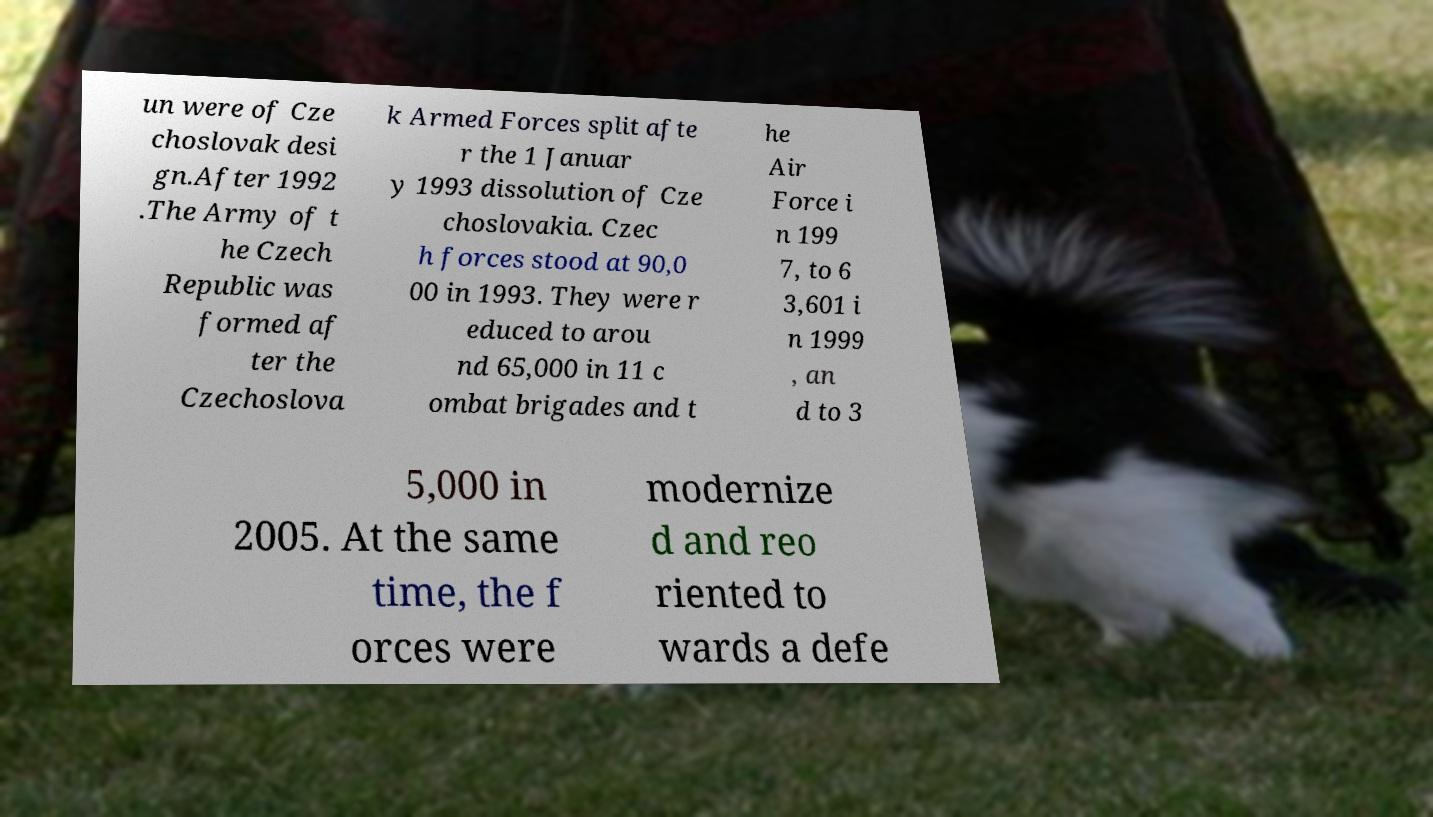Can you read and provide the text displayed in the image?This photo seems to have some interesting text. Can you extract and type it out for me? un were of Cze choslovak desi gn.After 1992 .The Army of t he Czech Republic was formed af ter the Czechoslova k Armed Forces split afte r the 1 Januar y 1993 dissolution of Cze choslovakia. Czec h forces stood at 90,0 00 in 1993. They were r educed to arou nd 65,000 in 11 c ombat brigades and t he Air Force i n 199 7, to 6 3,601 i n 1999 , an d to 3 5,000 in 2005. At the same time, the f orces were modernize d and reo riented to wards a defe 